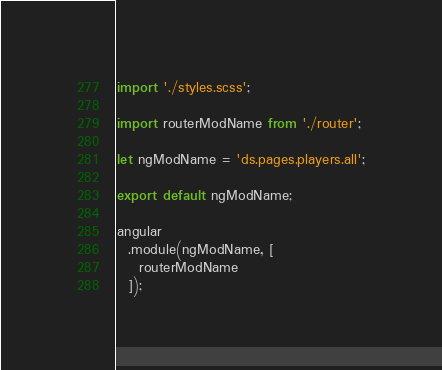<code> <loc_0><loc_0><loc_500><loc_500><_JavaScript_>import './styles.scss';

import routerModName from './router';

let ngModName = 'ds.pages.players.all';

export default ngModName;

angular
  .module(ngModName, [
    routerModName
  ]);
</code> 